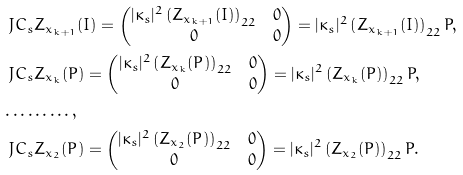Convert formula to latex. <formula><loc_0><loc_0><loc_500><loc_500>& \ J C _ { s } Z _ { x _ { k + 1 } } ( I ) = \begin{pmatrix} | \kappa _ { s } | ^ { 2 } \left ( Z _ { x _ { k + 1 } } ( I ) \right ) _ { 2 2 } & 0 \\ 0 & 0 \end{pmatrix} = | \kappa _ { s } | ^ { 2 } \left ( Z _ { x _ { k + 1 } } ( I ) \right ) _ { 2 2 } P , \\ & \ J C _ { s } Z _ { x _ { k } } ( P ) = \begin{pmatrix} | \kappa _ { s } | ^ { 2 } \left ( Z _ { x _ { k } } ( P ) \right ) _ { 2 2 } & 0 \\ 0 & 0 \end{pmatrix} = | \kappa _ { s } | ^ { 2 } \left ( Z _ { x _ { k } } ( P ) \right ) _ { 2 2 } P , \\ & \dots \dots \dots , \\ & \ J C _ { s } Z _ { x _ { 2 } } ( P ) = \begin{pmatrix} | \kappa _ { s } | ^ { 2 } \left ( Z _ { x _ { 2 } } ( P ) \right ) _ { 2 2 } & 0 \\ 0 & 0 \end{pmatrix} = | \kappa _ { s } | ^ { 2 } \left ( Z _ { x _ { 2 } } ( P ) \right ) _ { 2 2 } P .</formula> 